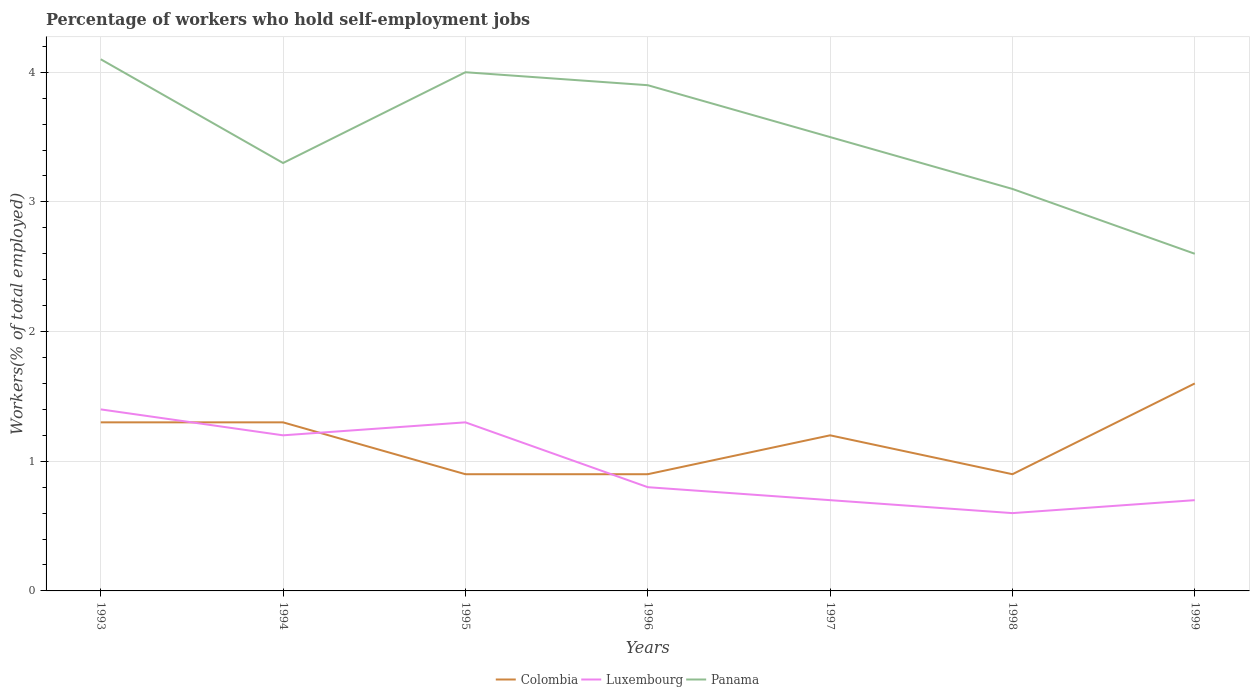Does the line corresponding to Colombia intersect with the line corresponding to Luxembourg?
Ensure brevity in your answer.  Yes. Is the number of lines equal to the number of legend labels?
Your answer should be compact. Yes. Across all years, what is the maximum percentage of self-employed workers in Luxembourg?
Make the answer very short. 0.6. What is the total percentage of self-employed workers in Colombia in the graph?
Ensure brevity in your answer.  0.4. What is the difference between the highest and the second highest percentage of self-employed workers in Colombia?
Your response must be concise. 0.7. Is the percentage of self-employed workers in Luxembourg strictly greater than the percentage of self-employed workers in Panama over the years?
Offer a very short reply. Yes. Does the graph contain any zero values?
Provide a short and direct response. No. Does the graph contain grids?
Make the answer very short. Yes. Where does the legend appear in the graph?
Your answer should be compact. Bottom center. How many legend labels are there?
Make the answer very short. 3. What is the title of the graph?
Keep it short and to the point. Percentage of workers who hold self-employment jobs. What is the label or title of the X-axis?
Your answer should be compact. Years. What is the label or title of the Y-axis?
Give a very brief answer. Workers(% of total employed). What is the Workers(% of total employed) in Colombia in 1993?
Offer a terse response. 1.3. What is the Workers(% of total employed) in Luxembourg in 1993?
Give a very brief answer. 1.4. What is the Workers(% of total employed) of Panama in 1993?
Keep it short and to the point. 4.1. What is the Workers(% of total employed) of Colombia in 1994?
Keep it short and to the point. 1.3. What is the Workers(% of total employed) in Luxembourg in 1994?
Offer a very short reply. 1.2. What is the Workers(% of total employed) in Panama in 1994?
Make the answer very short. 3.3. What is the Workers(% of total employed) of Colombia in 1995?
Make the answer very short. 0.9. What is the Workers(% of total employed) of Luxembourg in 1995?
Your answer should be compact. 1.3. What is the Workers(% of total employed) in Panama in 1995?
Provide a short and direct response. 4. What is the Workers(% of total employed) of Colombia in 1996?
Offer a very short reply. 0.9. What is the Workers(% of total employed) in Luxembourg in 1996?
Provide a short and direct response. 0.8. What is the Workers(% of total employed) of Panama in 1996?
Keep it short and to the point. 3.9. What is the Workers(% of total employed) in Colombia in 1997?
Provide a short and direct response. 1.2. What is the Workers(% of total employed) in Luxembourg in 1997?
Keep it short and to the point. 0.7. What is the Workers(% of total employed) of Panama in 1997?
Offer a terse response. 3.5. What is the Workers(% of total employed) of Colombia in 1998?
Provide a short and direct response. 0.9. What is the Workers(% of total employed) of Luxembourg in 1998?
Give a very brief answer. 0.6. What is the Workers(% of total employed) in Panama in 1998?
Ensure brevity in your answer.  3.1. What is the Workers(% of total employed) of Colombia in 1999?
Offer a terse response. 1.6. What is the Workers(% of total employed) of Luxembourg in 1999?
Ensure brevity in your answer.  0.7. What is the Workers(% of total employed) of Panama in 1999?
Provide a short and direct response. 2.6. Across all years, what is the maximum Workers(% of total employed) in Colombia?
Make the answer very short. 1.6. Across all years, what is the maximum Workers(% of total employed) in Luxembourg?
Give a very brief answer. 1.4. Across all years, what is the maximum Workers(% of total employed) in Panama?
Offer a very short reply. 4.1. Across all years, what is the minimum Workers(% of total employed) in Colombia?
Provide a succinct answer. 0.9. Across all years, what is the minimum Workers(% of total employed) of Luxembourg?
Ensure brevity in your answer.  0.6. Across all years, what is the minimum Workers(% of total employed) in Panama?
Offer a terse response. 2.6. What is the difference between the Workers(% of total employed) of Colombia in 1993 and that in 1995?
Your response must be concise. 0.4. What is the difference between the Workers(% of total employed) of Luxembourg in 1993 and that in 1995?
Your answer should be compact. 0.1. What is the difference between the Workers(% of total employed) in Panama in 1993 and that in 1995?
Keep it short and to the point. 0.1. What is the difference between the Workers(% of total employed) of Colombia in 1993 and that in 1996?
Provide a succinct answer. 0.4. What is the difference between the Workers(% of total employed) of Colombia in 1993 and that in 1997?
Offer a very short reply. 0.1. What is the difference between the Workers(% of total employed) in Luxembourg in 1993 and that in 1998?
Give a very brief answer. 0.8. What is the difference between the Workers(% of total employed) of Colombia in 1993 and that in 1999?
Provide a short and direct response. -0.3. What is the difference between the Workers(% of total employed) in Luxembourg in 1993 and that in 1999?
Ensure brevity in your answer.  0.7. What is the difference between the Workers(% of total employed) of Luxembourg in 1994 and that in 1995?
Ensure brevity in your answer.  -0.1. What is the difference between the Workers(% of total employed) of Colombia in 1994 and that in 1996?
Your response must be concise. 0.4. What is the difference between the Workers(% of total employed) of Luxembourg in 1994 and that in 1997?
Your answer should be compact. 0.5. What is the difference between the Workers(% of total employed) of Colombia in 1994 and that in 1998?
Ensure brevity in your answer.  0.4. What is the difference between the Workers(% of total employed) in Panama in 1994 and that in 1998?
Offer a terse response. 0.2. What is the difference between the Workers(% of total employed) in Colombia in 1994 and that in 1999?
Offer a very short reply. -0.3. What is the difference between the Workers(% of total employed) in Panama in 1994 and that in 1999?
Your answer should be very brief. 0.7. What is the difference between the Workers(% of total employed) in Colombia in 1995 and that in 1996?
Your answer should be very brief. 0. What is the difference between the Workers(% of total employed) of Panama in 1995 and that in 1996?
Provide a succinct answer. 0.1. What is the difference between the Workers(% of total employed) in Panama in 1995 and that in 1997?
Provide a short and direct response. 0.5. What is the difference between the Workers(% of total employed) of Luxembourg in 1995 and that in 1998?
Keep it short and to the point. 0.7. What is the difference between the Workers(% of total employed) of Colombia in 1995 and that in 1999?
Give a very brief answer. -0.7. What is the difference between the Workers(% of total employed) in Panama in 1995 and that in 1999?
Provide a short and direct response. 1.4. What is the difference between the Workers(% of total employed) of Panama in 1996 and that in 1998?
Make the answer very short. 0.8. What is the difference between the Workers(% of total employed) of Colombia in 1996 and that in 1999?
Give a very brief answer. -0.7. What is the difference between the Workers(% of total employed) in Luxembourg in 1996 and that in 1999?
Your answer should be compact. 0.1. What is the difference between the Workers(% of total employed) in Panama in 1996 and that in 1999?
Offer a terse response. 1.3. What is the difference between the Workers(% of total employed) of Colombia in 1997 and that in 1998?
Offer a terse response. 0.3. What is the difference between the Workers(% of total employed) of Luxembourg in 1997 and that in 1998?
Provide a short and direct response. 0.1. What is the difference between the Workers(% of total employed) of Panama in 1997 and that in 1998?
Offer a very short reply. 0.4. What is the difference between the Workers(% of total employed) of Luxembourg in 1997 and that in 1999?
Your answer should be very brief. 0. What is the difference between the Workers(% of total employed) of Colombia in 1998 and that in 1999?
Provide a short and direct response. -0.7. What is the difference between the Workers(% of total employed) of Colombia in 1993 and the Workers(% of total employed) of Luxembourg in 1994?
Provide a succinct answer. 0.1. What is the difference between the Workers(% of total employed) of Colombia in 1993 and the Workers(% of total employed) of Panama in 1994?
Offer a terse response. -2. What is the difference between the Workers(% of total employed) of Luxembourg in 1993 and the Workers(% of total employed) of Panama in 1995?
Offer a terse response. -2.6. What is the difference between the Workers(% of total employed) in Colombia in 1993 and the Workers(% of total employed) in Panama in 1996?
Provide a succinct answer. -2.6. What is the difference between the Workers(% of total employed) of Luxembourg in 1993 and the Workers(% of total employed) of Panama in 1997?
Ensure brevity in your answer.  -2.1. What is the difference between the Workers(% of total employed) in Colombia in 1993 and the Workers(% of total employed) in Luxembourg in 1999?
Your response must be concise. 0.6. What is the difference between the Workers(% of total employed) in Colombia in 1994 and the Workers(% of total employed) in Luxembourg in 1995?
Your answer should be compact. 0. What is the difference between the Workers(% of total employed) of Colombia in 1994 and the Workers(% of total employed) of Panama in 1995?
Ensure brevity in your answer.  -2.7. What is the difference between the Workers(% of total employed) in Luxembourg in 1994 and the Workers(% of total employed) in Panama in 1996?
Offer a very short reply. -2.7. What is the difference between the Workers(% of total employed) in Colombia in 1994 and the Workers(% of total employed) in Luxembourg in 1997?
Your answer should be compact. 0.6. What is the difference between the Workers(% of total employed) of Luxembourg in 1994 and the Workers(% of total employed) of Panama in 1997?
Your response must be concise. -2.3. What is the difference between the Workers(% of total employed) in Colombia in 1994 and the Workers(% of total employed) in Luxembourg in 1998?
Provide a succinct answer. 0.7. What is the difference between the Workers(% of total employed) in Colombia in 1994 and the Workers(% of total employed) in Luxembourg in 1999?
Make the answer very short. 0.6. What is the difference between the Workers(% of total employed) of Colombia in 1995 and the Workers(% of total employed) of Luxembourg in 1996?
Your answer should be compact. 0.1. What is the difference between the Workers(% of total employed) of Luxembourg in 1995 and the Workers(% of total employed) of Panama in 1996?
Your answer should be compact. -2.6. What is the difference between the Workers(% of total employed) in Colombia in 1995 and the Workers(% of total employed) in Luxembourg in 1997?
Offer a very short reply. 0.2. What is the difference between the Workers(% of total employed) of Colombia in 1995 and the Workers(% of total employed) of Panama in 1997?
Provide a short and direct response. -2.6. What is the difference between the Workers(% of total employed) in Luxembourg in 1995 and the Workers(% of total employed) in Panama in 1997?
Your response must be concise. -2.2. What is the difference between the Workers(% of total employed) of Colombia in 1995 and the Workers(% of total employed) of Panama in 1998?
Provide a short and direct response. -2.2. What is the difference between the Workers(% of total employed) of Luxembourg in 1995 and the Workers(% of total employed) of Panama in 1998?
Make the answer very short. -1.8. What is the difference between the Workers(% of total employed) in Colombia in 1995 and the Workers(% of total employed) in Luxembourg in 1999?
Ensure brevity in your answer.  0.2. What is the difference between the Workers(% of total employed) in Colombia in 1995 and the Workers(% of total employed) in Panama in 1999?
Make the answer very short. -1.7. What is the difference between the Workers(% of total employed) in Colombia in 1996 and the Workers(% of total employed) in Luxembourg in 1997?
Keep it short and to the point. 0.2. What is the difference between the Workers(% of total employed) of Colombia in 1996 and the Workers(% of total employed) of Panama in 1997?
Your response must be concise. -2.6. What is the difference between the Workers(% of total employed) in Luxembourg in 1996 and the Workers(% of total employed) in Panama in 1997?
Give a very brief answer. -2.7. What is the difference between the Workers(% of total employed) in Colombia in 1996 and the Workers(% of total employed) in Luxembourg in 1998?
Ensure brevity in your answer.  0.3. What is the difference between the Workers(% of total employed) of Colombia in 1996 and the Workers(% of total employed) of Panama in 1999?
Give a very brief answer. -1.7. What is the difference between the Workers(% of total employed) of Colombia in 1997 and the Workers(% of total employed) of Luxembourg in 1998?
Ensure brevity in your answer.  0.6. What is the difference between the Workers(% of total employed) in Colombia in 1997 and the Workers(% of total employed) in Panama in 1998?
Offer a terse response. -1.9. What is the difference between the Workers(% of total employed) of Colombia in 1997 and the Workers(% of total employed) of Panama in 1999?
Offer a very short reply. -1.4. What is the difference between the Workers(% of total employed) in Luxembourg in 1997 and the Workers(% of total employed) in Panama in 1999?
Offer a very short reply. -1.9. What is the difference between the Workers(% of total employed) of Colombia in 1998 and the Workers(% of total employed) of Panama in 1999?
Your answer should be very brief. -1.7. What is the difference between the Workers(% of total employed) in Luxembourg in 1998 and the Workers(% of total employed) in Panama in 1999?
Provide a short and direct response. -2. What is the average Workers(% of total employed) of Colombia per year?
Your answer should be very brief. 1.16. What is the average Workers(% of total employed) in Luxembourg per year?
Offer a terse response. 0.96. In the year 1993, what is the difference between the Workers(% of total employed) of Colombia and Workers(% of total employed) of Panama?
Offer a terse response. -2.8. In the year 1994, what is the difference between the Workers(% of total employed) in Colombia and Workers(% of total employed) in Luxembourg?
Give a very brief answer. 0.1. In the year 1995, what is the difference between the Workers(% of total employed) of Colombia and Workers(% of total employed) of Panama?
Offer a terse response. -3.1. In the year 1996, what is the difference between the Workers(% of total employed) of Colombia and Workers(% of total employed) of Luxembourg?
Ensure brevity in your answer.  0.1. In the year 1996, what is the difference between the Workers(% of total employed) of Colombia and Workers(% of total employed) of Panama?
Ensure brevity in your answer.  -3. In the year 1997, what is the difference between the Workers(% of total employed) of Luxembourg and Workers(% of total employed) of Panama?
Your answer should be very brief. -2.8. In the year 1998, what is the difference between the Workers(% of total employed) in Colombia and Workers(% of total employed) in Luxembourg?
Provide a short and direct response. 0.3. In the year 1999, what is the difference between the Workers(% of total employed) in Colombia and Workers(% of total employed) in Luxembourg?
Make the answer very short. 0.9. What is the ratio of the Workers(% of total employed) of Panama in 1993 to that in 1994?
Offer a very short reply. 1.24. What is the ratio of the Workers(% of total employed) in Colombia in 1993 to that in 1995?
Make the answer very short. 1.44. What is the ratio of the Workers(% of total employed) in Colombia in 1993 to that in 1996?
Offer a very short reply. 1.44. What is the ratio of the Workers(% of total employed) in Luxembourg in 1993 to that in 1996?
Offer a terse response. 1.75. What is the ratio of the Workers(% of total employed) of Panama in 1993 to that in 1996?
Offer a terse response. 1.05. What is the ratio of the Workers(% of total employed) in Colombia in 1993 to that in 1997?
Give a very brief answer. 1.08. What is the ratio of the Workers(% of total employed) of Panama in 1993 to that in 1997?
Ensure brevity in your answer.  1.17. What is the ratio of the Workers(% of total employed) in Colombia in 1993 to that in 1998?
Your answer should be compact. 1.44. What is the ratio of the Workers(% of total employed) in Luxembourg in 1993 to that in 1998?
Offer a very short reply. 2.33. What is the ratio of the Workers(% of total employed) in Panama in 1993 to that in 1998?
Offer a very short reply. 1.32. What is the ratio of the Workers(% of total employed) in Colombia in 1993 to that in 1999?
Keep it short and to the point. 0.81. What is the ratio of the Workers(% of total employed) of Luxembourg in 1993 to that in 1999?
Your response must be concise. 2. What is the ratio of the Workers(% of total employed) in Panama in 1993 to that in 1999?
Provide a short and direct response. 1.58. What is the ratio of the Workers(% of total employed) of Colombia in 1994 to that in 1995?
Your answer should be very brief. 1.44. What is the ratio of the Workers(% of total employed) of Panama in 1994 to that in 1995?
Keep it short and to the point. 0.82. What is the ratio of the Workers(% of total employed) in Colombia in 1994 to that in 1996?
Your answer should be compact. 1.44. What is the ratio of the Workers(% of total employed) in Panama in 1994 to that in 1996?
Provide a short and direct response. 0.85. What is the ratio of the Workers(% of total employed) in Colombia in 1994 to that in 1997?
Keep it short and to the point. 1.08. What is the ratio of the Workers(% of total employed) of Luxembourg in 1994 to that in 1997?
Offer a very short reply. 1.71. What is the ratio of the Workers(% of total employed) of Panama in 1994 to that in 1997?
Your response must be concise. 0.94. What is the ratio of the Workers(% of total employed) of Colombia in 1994 to that in 1998?
Provide a short and direct response. 1.44. What is the ratio of the Workers(% of total employed) of Luxembourg in 1994 to that in 1998?
Ensure brevity in your answer.  2. What is the ratio of the Workers(% of total employed) of Panama in 1994 to that in 1998?
Keep it short and to the point. 1.06. What is the ratio of the Workers(% of total employed) in Colombia in 1994 to that in 1999?
Provide a succinct answer. 0.81. What is the ratio of the Workers(% of total employed) of Luxembourg in 1994 to that in 1999?
Keep it short and to the point. 1.71. What is the ratio of the Workers(% of total employed) in Panama in 1994 to that in 1999?
Offer a very short reply. 1.27. What is the ratio of the Workers(% of total employed) in Colombia in 1995 to that in 1996?
Your answer should be compact. 1. What is the ratio of the Workers(% of total employed) in Luxembourg in 1995 to that in 1996?
Keep it short and to the point. 1.62. What is the ratio of the Workers(% of total employed) of Panama in 1995 to that in 1996?
Offer a terse response. 1.03. What is the ratio of the Workers(% of total employed) in Colombia in 1995 to that in 1997?
Ensure brevity in your answer.  0.75. What is the ratio of the Workers(% of total employed) in Luxembourg in 1995 to that in 1997?
Your answer should be very brief. 1.86. What is the ratio of the Workers(% of total employed) of Panama in 1995 to that in 1997?
Offer a very short reply. 1.14. What is the ratio of the Workers(% of total employed) in Luxembourg in 1995 to that in 1998?
Offer a very short reply. 2.17. What is the ratio of the Workers(% of total employed) in Panama in 1995 to that in 1998?
Your answer should be compact. 1.29. What is the ratio of the Workers(% of total employed) of Colombia in 1995 to that in 1999?
Provide a short and direct response. 0.56. What is the ratio of the Workers(% of total employed) in Luxembourg in 1995 to that in 1999?
Give a very brief answer. 1.86. What is the ratio of the Workers(% of total employed) in Panama in 1995 to that in 1999?
Provide a succinct answer. 1.54. What is the ratio of the Workers(% of total employed) of Luxembourg in 1996 to that in 1997?
Provide a short and direct response. 1.14. What is the ratio of the Workers(% of total employed) in Panama in 1996 to that in 1997?
Provide a short and direct response. 1.11. What is the ratio of the Workers(% of total employed) in Colombia in 1996 to that in 1998?
Your answer should be compact. 1. What is the ratio of the Workers(% of total employed) in Luxembourg in 1996 to that in 1998?
Provide a succinct answer. 1.33. What is the ratio of the Workers(% of total employed) of Panama in 1996 to that in 1998?
Your response must be concise. 1.26. What is the ratio of the Workers(% of total employed) in Colombia in 1996 to that in 1999?
Make the answer very short. 0.56. What is the ratio of the Workers(% of total employed) in Luxembourg in 1996 to that in 1999?
Provide a short and direct response. 1.14. What is the ratio of the Workers(% of total employed) in Panama in 1996 to that in 1999?
Your response must be concise. 1.5. What is the ratio of the Workers(% of total employed) of Luxembourg in 1997 to that in 1998?
Provide a short and direct response. 1.17. What is the ratio of the Workers(% of total employed) of Panama in 1997 to that in 1998?
Your response must be concise. 1.13. What is the ratio of the Workers(% of total employed) of Colombia in 1997 to that in 1999?
Keep it short and to the point. 0.75. What is the ratio of the Workers(% of total employed) of Panama in 1997 to that in 1999?
Your answer should be compact. 1.35. What is the ratio of the Workers(% of total employed) of Colombia in 1998 to that in 1999?
Make the answer very short. 0.56. What is the ratio of the Workers(% of total employed) of Panama in 1998 to that in 1999?
Ensure brevity in your answer.  1.19. What is the difference between the highest and the lowest Workers(% of total employed) of Colombia?
Make the answer very short. 0.7. What is the difference between the highest and the lowest Workers(% of total employed) in Luxembourg?
Your response must be concise. 0.8. What is the difference between the highest and the lowest Workers(% of total employed) in Panama?
Your response must be concise. 1.5. 